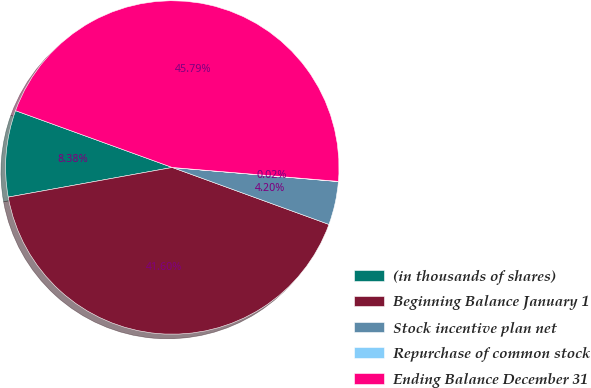Convert chart to OTSL. <chart><loc_0><loc_0><loc_500><loc_500><pie_chart><fcel>(in thousands of shares)<fcel>Beginning Balance January 1<fcel>Stock incentive plan net<fcel>Repurchase of common stock<fcel>Ending Balance December 31<nl><fcel>8.38%<fcel>41.6%<fcel>4.2%<fcel>0.02%<fcel>45.79%<nl></chart> 